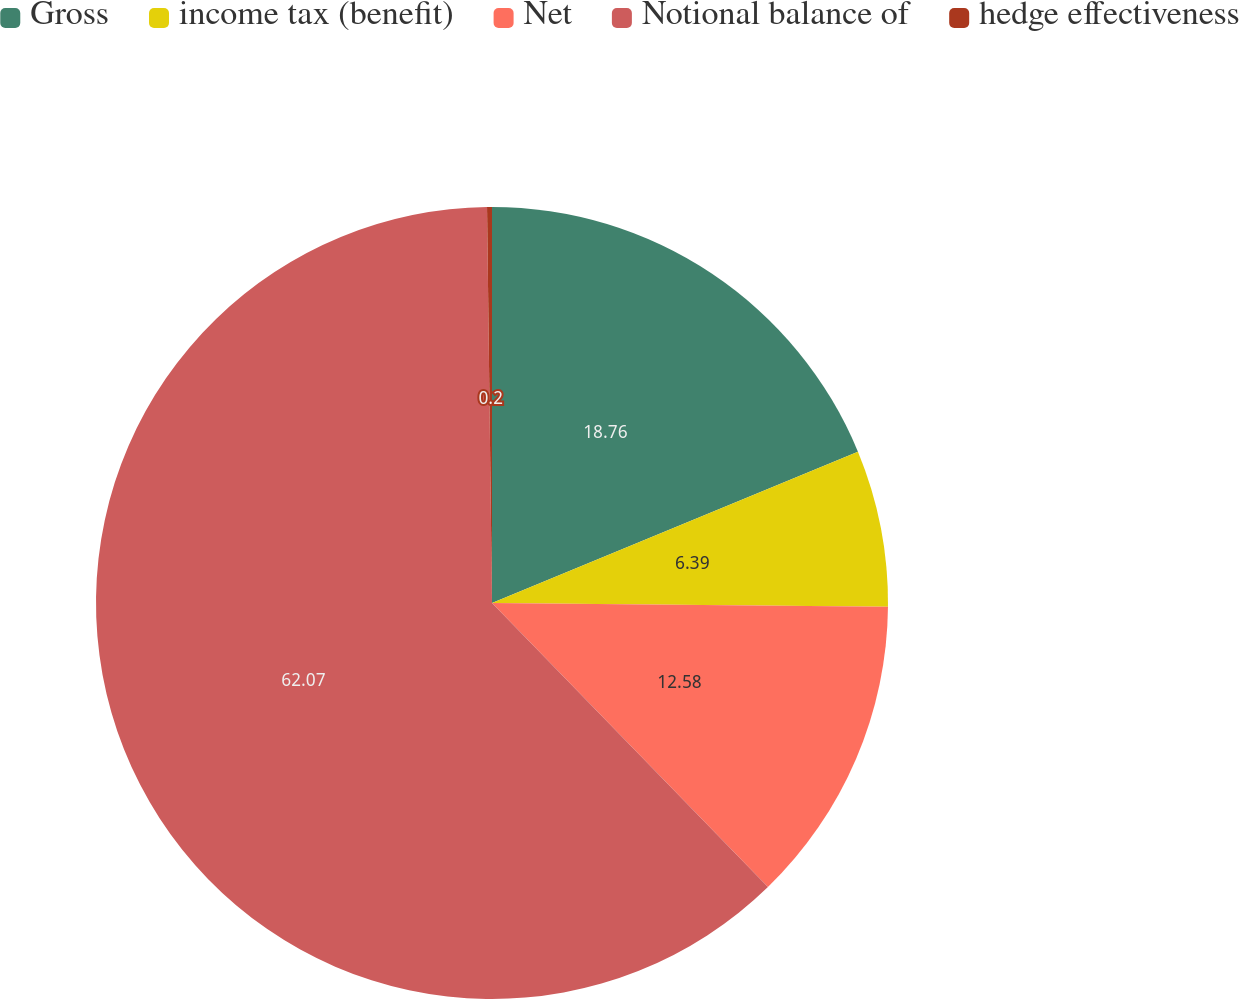Convert chart to OTSL. <chart><loc_0><loc_0><loc_500><loc_500><pie_chart><fcel>Gross<fcel>income tax (benefit)<fcel>Net<fcel>Notional balance of<fcel>hedge effectiveness<nl><fcel>18.76%<fcel>6.39%<fcel>12.58%<fcel>62.07%<fcel>0.2%<nl></chart> 